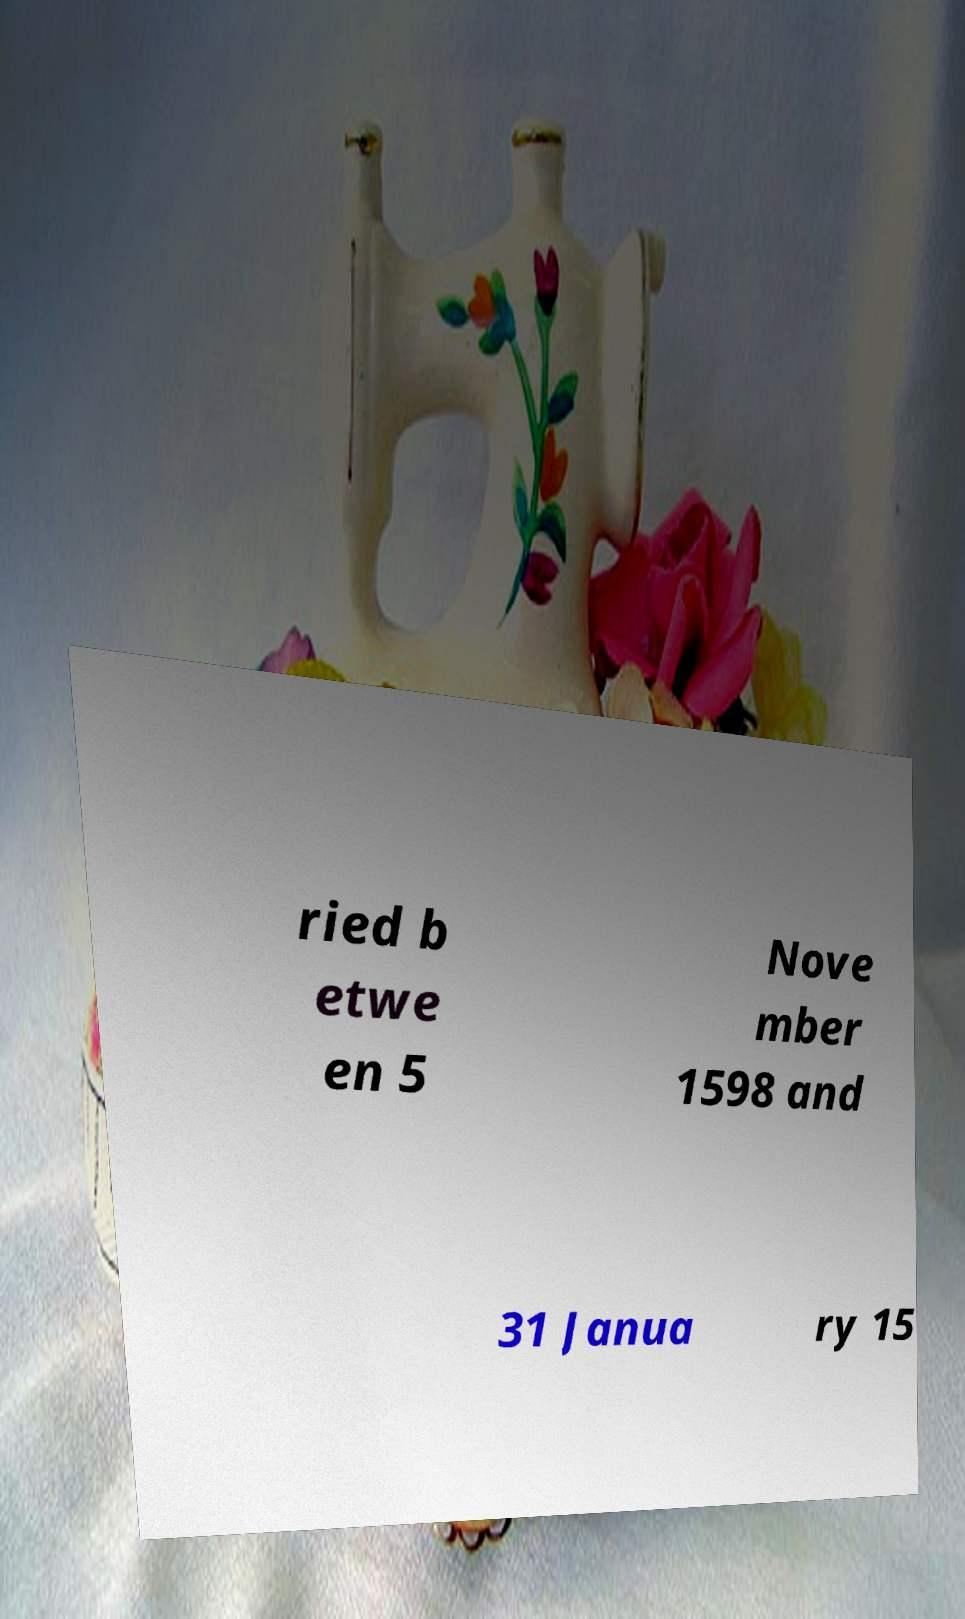I need the written content from this picture converted into text. Can you do that? ried b etwe en 5 Nove mber 1598 and 31 Janua ry 15 